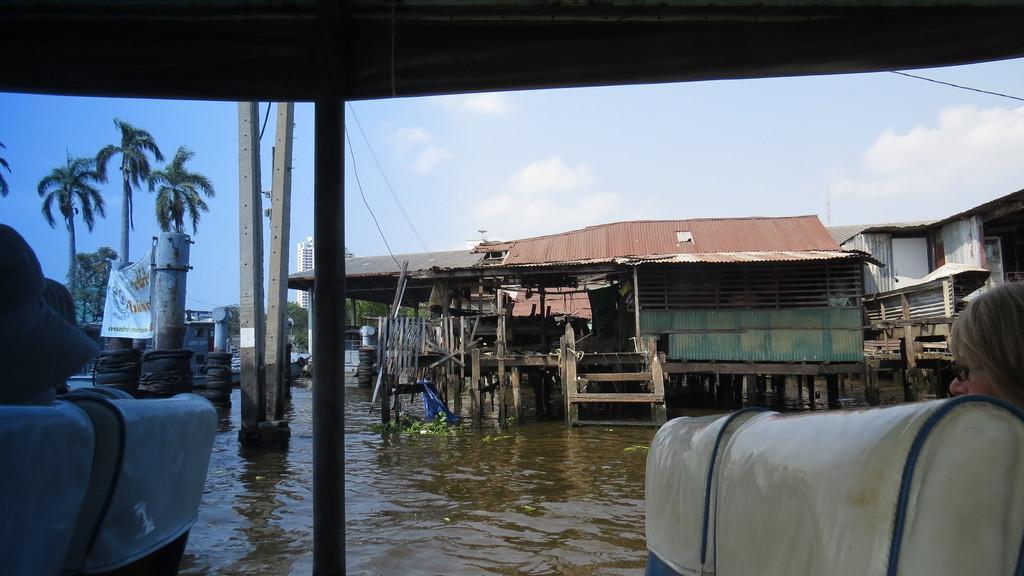In one or two sentences, can you explain what this image depicts? In this picture we can see some people are sitting and behind the people there is water, houses, electric pole, cables, building, trees and a sky. 